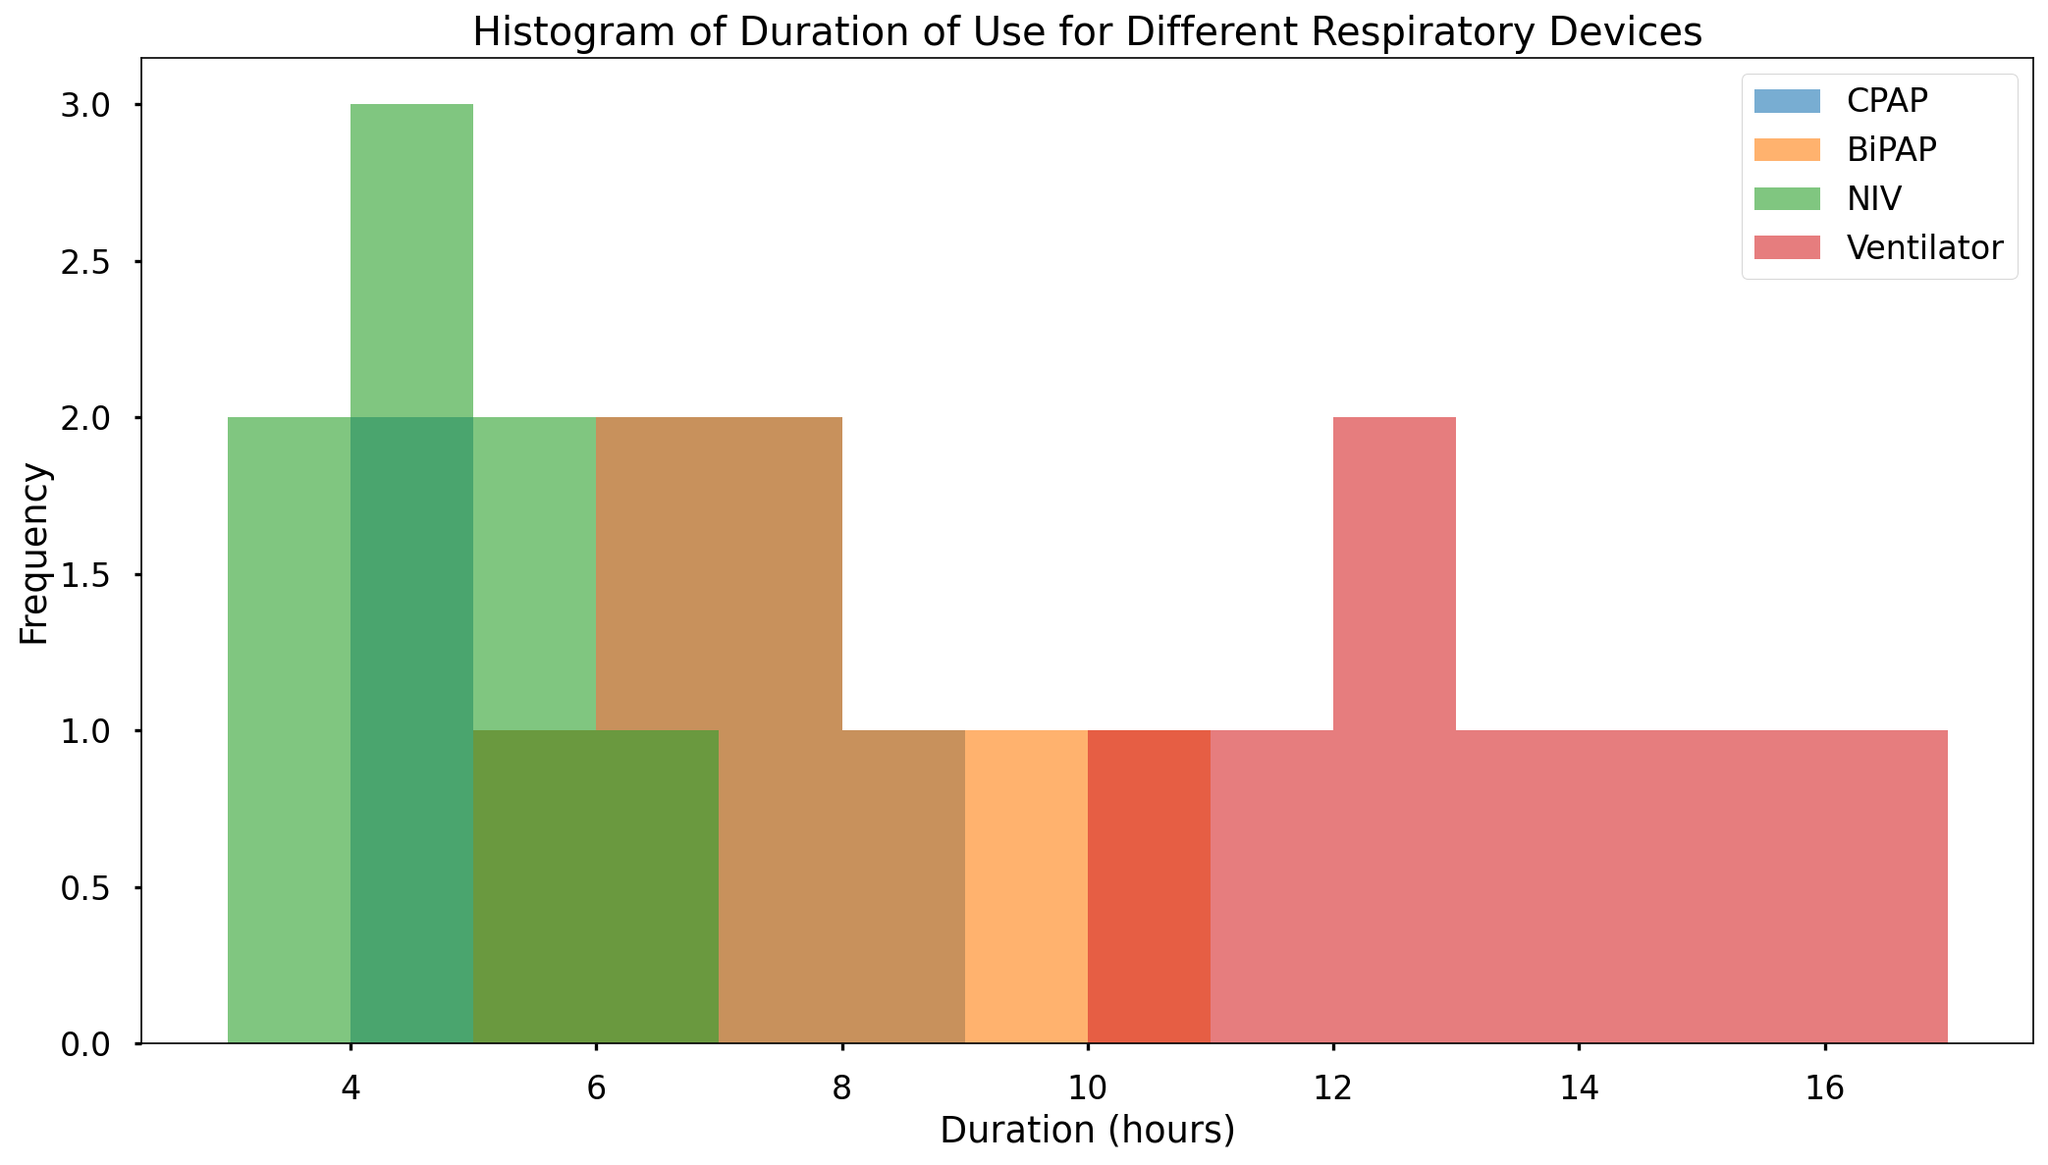What is the most frequently used duration for CPAP devices? The histogram shows the frequency of different durations for using CPAP devices. By observing the heights of the bars for CPAP, the duration with the highest bar represents the most frequent duration.
Answer: 6 hours Which device has the highest peak in their histogram? By comparing the heights of the highest bars for each device in the histogram, identify the device with the tallest bar.
Answer: Ventilator Which device shows the most variability in duration of use? Variability can be assessed by looking at the spread of the histogram bars. The device with the bars spread over the widest range of durations shows the most variability.
Answer: Ventilator What is the difference between the longest and shortest duration documented for NIV devices? The histogram for NIV devices shows durations from 3 to 6 hours. To find the difference, subtract the shortest duration from the longest duration.
Answer: 3 hours Which device has the shortest duration of use? By identifying the leftmost bar in the histogram, we can determine which device has the shortest duration of use.
Answer: NIV How does the range of durations for BiPAP compare to CPAP? Examining both histograms, the durations for BiPAP range from 5 to 10 hours, and for CPAP, they range from 4 to 8 hours. Compare these ranges to determine the difference.
Answer: BiPAP has a wider range What is the average duration of use for CPAP devices? To calculate the average, sum all the durations for CPAP and divide by the number of observations. The durations for CPAP are 4, 6, 5, 7, 4.5, 6.5, 8, and 7.5. The sum is 48.5, and there are 8 observations. Average = 48.5 / 8 = 6.06 hours.
Answer: 6.06 hours Which device has the most consistent duration of use? Consistency can be assessed by the clustering of bars around a central value. The device with bars tightly grouped around a central duration shows the most consistency.
Answer: NIV 